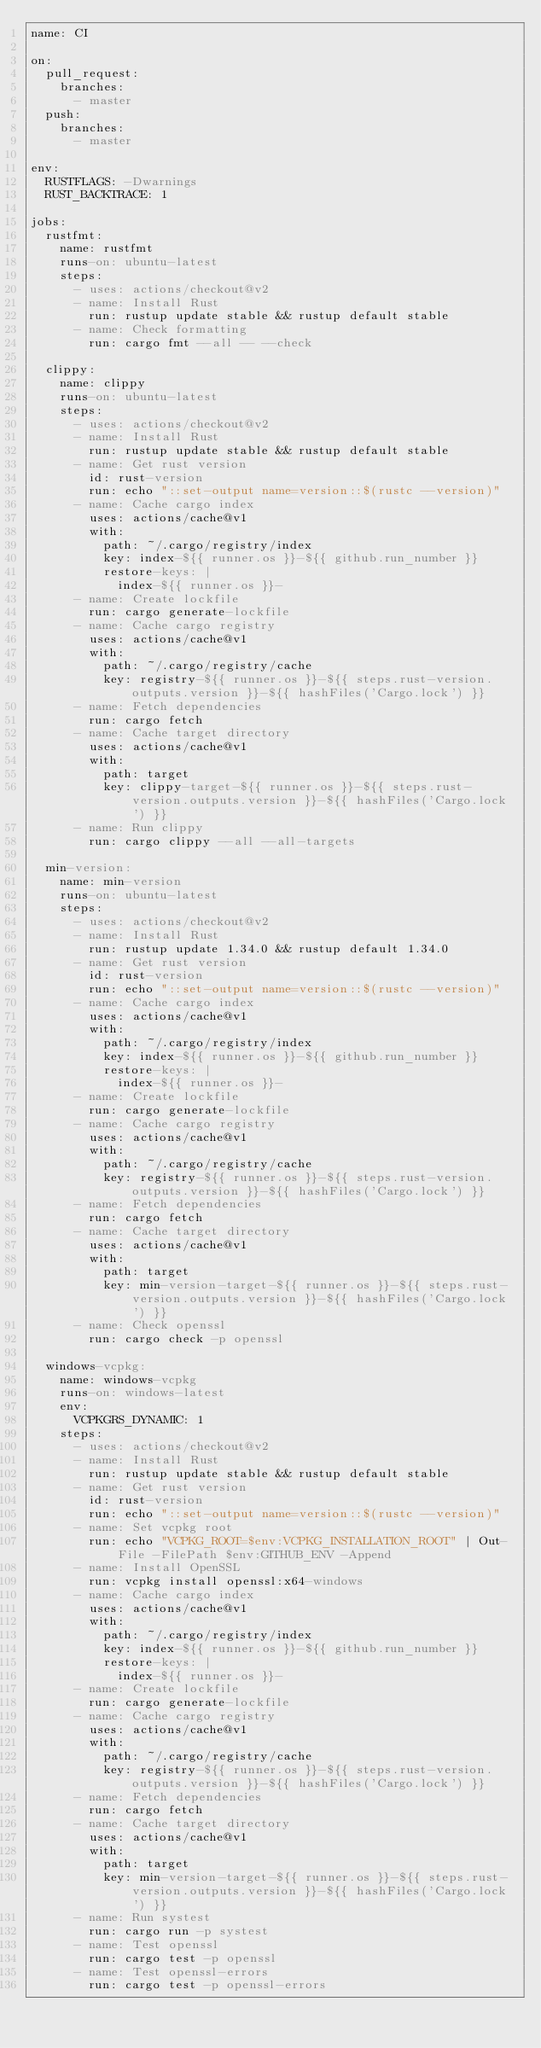Convert code to text. <code><loc_0><loc_0><loc_500><loc_500><_YAML_>name: CI

on:
  pull_request:
    branches:
      - master
  push:
    branches:
      - master

env:
  RUSTFLAGS: -Dwarnings
  RUST_BACKTRACE: 1

jobs:
  rustfmt:
    name: rustfmt
    runs-on: ubuntu-latest
    steps:
      - uses: actions/checkout@v2
      - name: Install Rust
        run: rustup update stable && rustup default stable
      - name: Check formatting
        run: cargo fmt --all -- --check

  clippy:
    name: clippy
    runs-on: ubuntu-latest
    steps:
      - uses: actions/checkout@v2
      - name: Install Rust
        run: rustup update stable && rustup default stable
      - name: Get rust version
        id: rust-version
        run: echo "::set-output name=version::$(rustc --version)"
      - name: Cache cargo index
        uses: actions/cache@v1
        with:
          path: ~/.cargo/registry/index
          key: index-${{ runner.os }}-${{ github.run_number }}
          restore-keys: |
            index-${{ runner.os }}-
      - name: Create lockfile
        run: cargo generate-lockfile
      - name: Cache cargo registry
        uses: actions/cache@v1
        with:
          path: ~/.cargo/registry/cache
          key: registry-${{ runner.os }}-${{ steps.rust-version.outputs.version }}-${{ hashFiles('Cargo.lock') }}
      - name: Fetch dependencies
        run: cargo fetch
      - name: Cache target directory
        uses: actions/cache@v1
        with:
          path: target
          key: clippy-target-${{ runner.os }}-${{ steps.rust-version.outputs.version }}-${{ hashFiles('Cargo.lock') }}
      - name: Run clippy
        run: cargo clippy --all --all-targets

  min-version:
    name: min-version
    runs-on: ubuntu-latest
    steps:
      - uses: actions/checkout@v2
      - name: Install Rust
        run: rustup update 1.34.0 && rustup default 1.34.0
      - name: Get rust version
        id: rust-version
        run: echo "::set-output name=version::$(rustc --version)"
      - name: Cache cargo index
        uses: actions/cache@v1
        with:
          path: ~/.cargo/registry/index
          key: index-${{ runner.os }}-${{ github.run_number }}
          restore-keys: |
            index-${{ runner.os }}-
      - name: Create lockfile
        run: cargo generate-lockfile
      - name: Cache cargo registry
        uses: actions/cache@v1
        with:
          path: ~/.cargo/registry/cache
          key: registry-${{ runner.os }}-${{ steps.rust-version.outputs.version }}-${{ hashFiles('Cargo.lock') }}
      - name: Fetch dependencies
        run: cargo fetch
      - name: Cache target directory
        uses: actions/cache@v1
        with:
          path: target
          key: min-version-target-${{ runner.os }}-${{ steps.rust-version.outputs.version }}-${{ hashFiles('Cargo.lock') }}
      - name: Check openssl
        run: cargo check -p openssl

  windows-vcpkg:
    name: windows-vcpkg
    runs-on: windows-latest
    env:
      VCPKGRS_DYNAMIC: 1
    steps:
      - uses: actions/checkout@v2
      - name: Install Rust
        run: rustup update stable && rustup default stable
      - name: Get rust version
        id: rust-version
        run: echo "::set-output name=version::$(rustc --version)"
      - name: Set vcpkg root
        run: echo "VCPKG_ROOT=$env:VCPKG_INSTALLATION_ROOT" | Out-File -FilePath $env:GITHUB_ENV -Append
      - name: Install OpenSSL
        run: vcpkg install openssl:x64-windows
      - name: Cache cargo index
        uses: actions/cache@v1
        with:
          path: ~/.cargo/registry/index
          key: index-${{ runner.os }}-${{ github.run_number }}
          restore-keys: |
            index-${{ runner.os }}-
      - name: Create lockfile
        run: cargo generate-lockfile
      - name: Cache cargo registry
        uses: actions/cache@v1
        with:
          path: ~/.cargo/registry/cache
          key: registry-${{ runner.os }}-${{ steps.rust-version.outputs.version }}-${{ hashFiles('Cargo.lock') }}
      - name: Fetch dependencies
        run: cargo fetch
      - name: Cache target directory
        uses: actions/cache@v1
        with:
          path: target
          key: min-version-target-${{ runner.os }}-${{ steps.rust-version.outputs.version }}-${{ hashFiles('Cargo.lock') }}
      - name: Run systest
        run: cargo run -p systest
      - name: Test openssl
        run: cargo test -p openssl
      - name: Test openssl-errors
        run: cargo test -p openssl-errors
</code> 